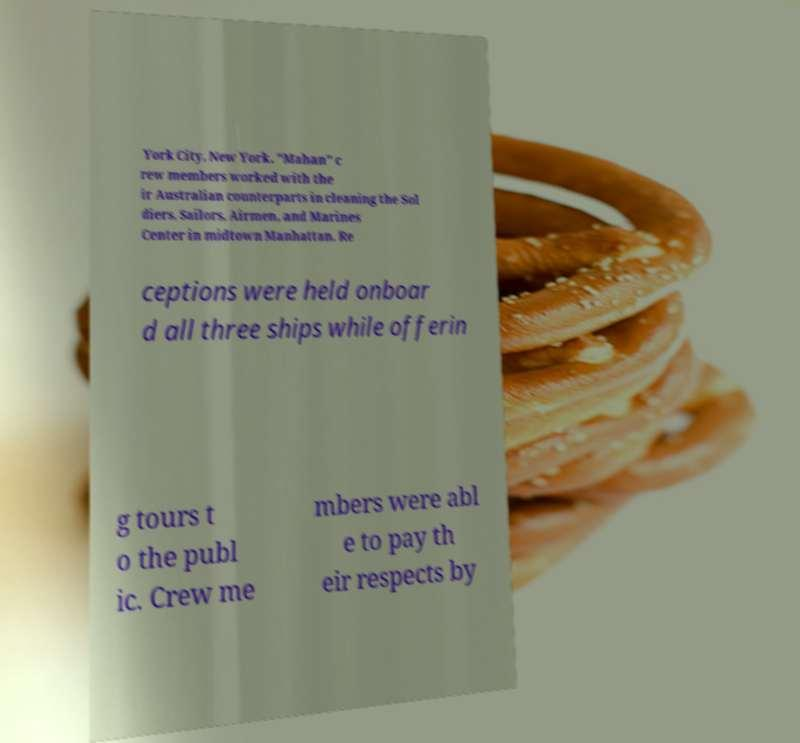Please read and relay the text visible in this image. What does it say? York City, New York. "Mahan" c rew members worked with the ir Australian counterparts in cleaning the Sol diers, Sailors, Airmen, and Marines Center in midtown Manhattan. Re ceptions were held onboar d all three ships while offerin g tours t o the publ ic. Crew me mbers were abl e to pay th eir respects by 